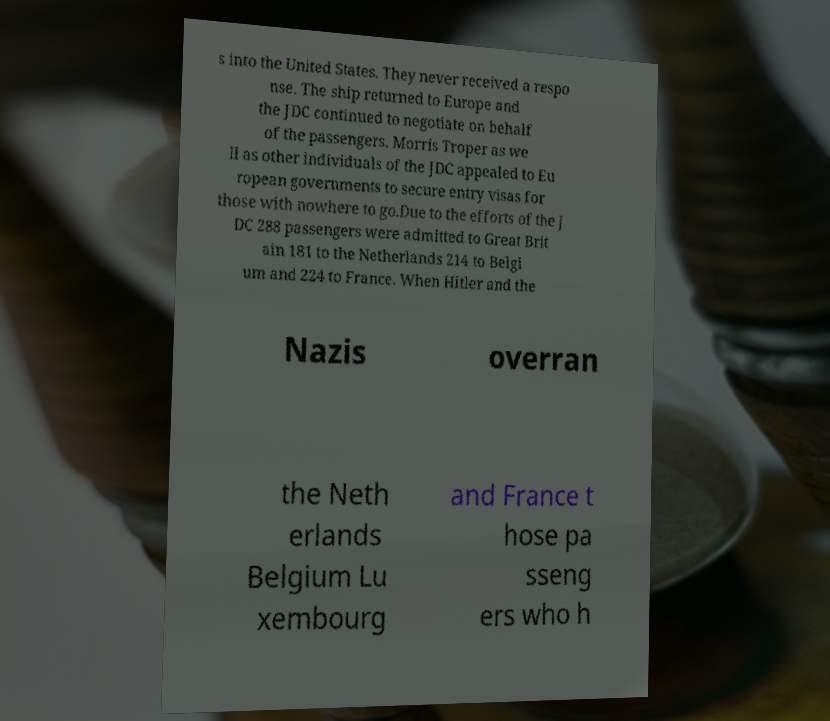Can you read and provide the text displayed in the image?This photo seems to have some interesting text. Can you extract and type it out for me? s into the United States. They never received a respo nse. The ship returned to Europe and the JDC continued to negotiate on behalf of the passengers. Morris Troper as we ll as other individuals of the JDC appealed to Eu ropean governments to secure entry visas for those with nowhere to go.Due to the efforts of the J DC 288 passengers were admitted to Great Brit ain 181 to the Netherlands 214 to Belgi um and 224 to France. When Hitler and the Nazis overran the Neth erlands Belgium Lu xembourg and France t hose pa sseng ers who h 